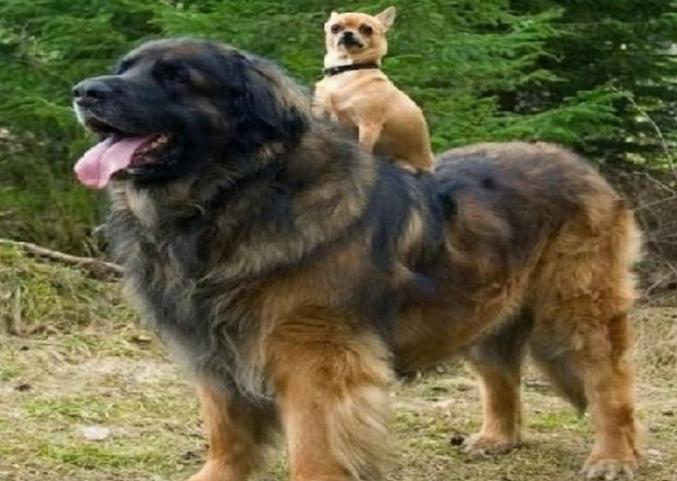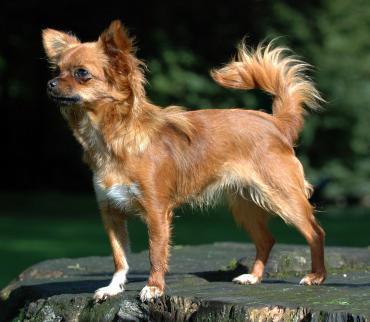The first image is the image on the left, the second image is the image on the right. Evaluate the accuracy of this statement regarding the images: "There are three dogs shown". Is it true? Answer yes or no. Yes. The first image is the image on the left, the second image is the image on the right. Considering the images on both sides, is "The right image contains at least two chihuahua's." valid? Answer yes or no. No. 